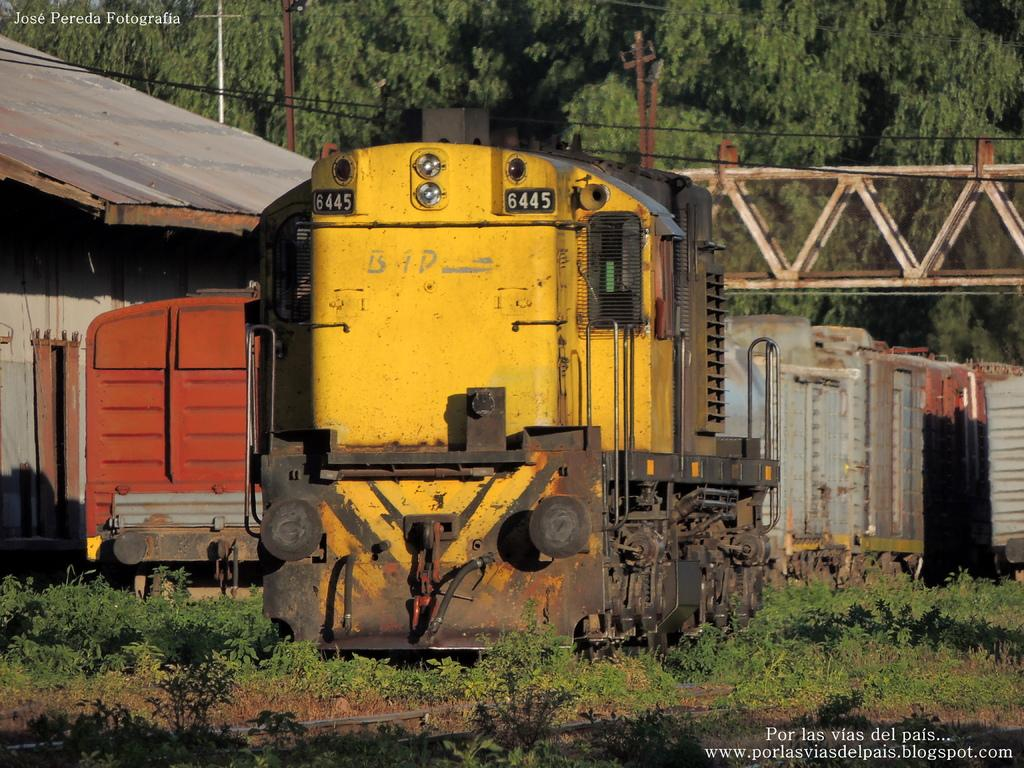What type of transportation is depicted in the image? There are train compartments in the image. Where are the train compartments located? The train compartments are on a land. What can be seen in the background of the image? There is a bridge in the background of the image, and many trees are behind the bridge. Can you see a dog or a goat in the image? No, there are no dogs or goats present in the image. What is the train conductor saying to the passengers as they depart the train? The provided facts do not mention any dialogue or interactions between the passengers and the train conductor, so we cannot determine what the train conductor is saying. 